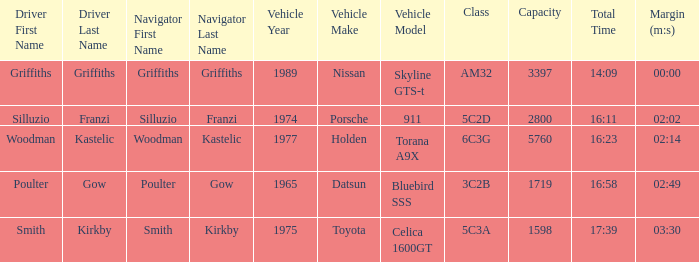What's the lowest capacity when the margin is 03:30? 1598.0. 